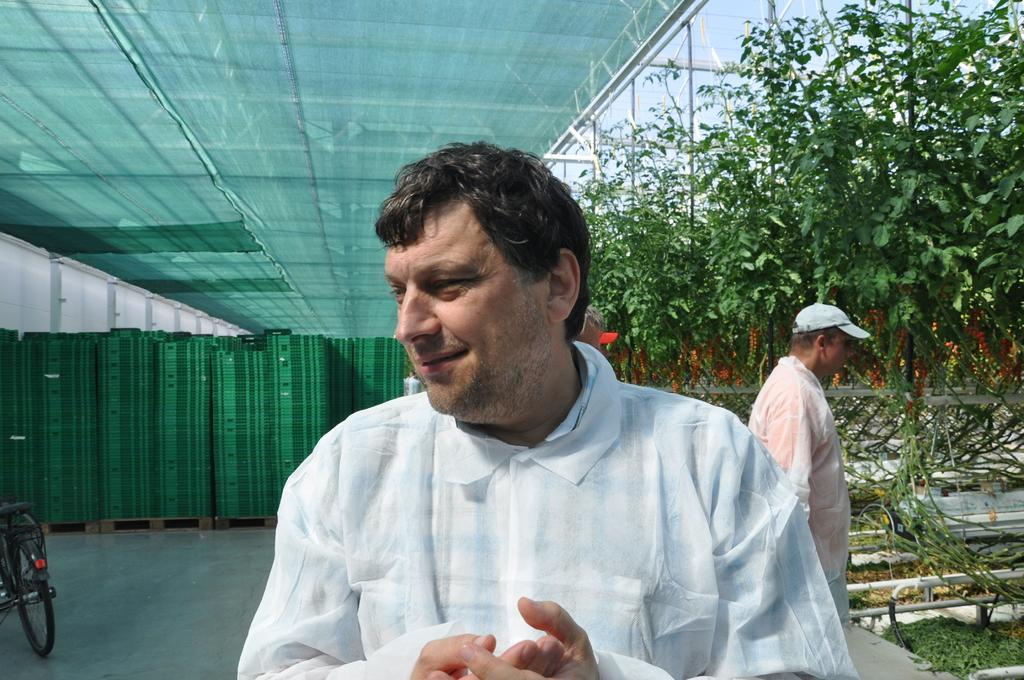How many people are in the image? There are two persons in the image. What can be seen in the background of the image? There are trees in the image. What object is located on the left side of the image? There is a bicycle on the left side of the image. What color is the cloth visible at the top of the image? The cloth visible at the top of the image is green. How many chickens are present in the image? There are no chickens present in the image. What type of maid is visible in the image? There is no maid present in the image. 